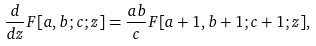<formula> <loc_0><loc_0><loc_500><loc_500>\frac { d } { d z } F [ a , b ; c ; z ] = \frac { a b } { c } F [ a + 1 , b + 1 ; c + 1 ; z ] ,</formula> 